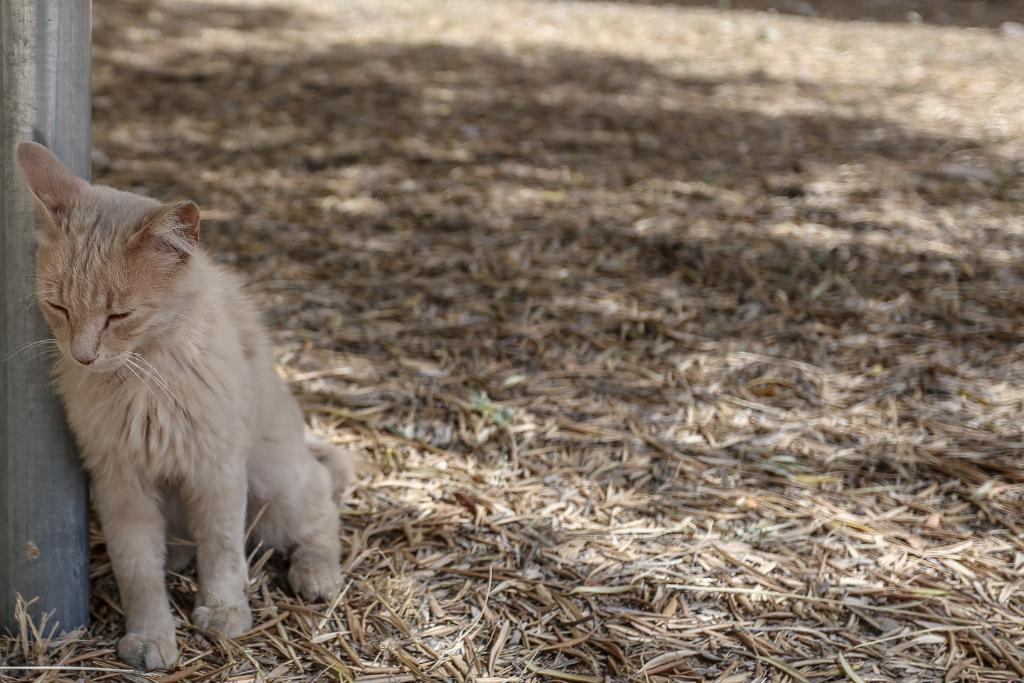What animal can be seen in the image? There is a cat in the image. What is the cat doing in the image? The cat is leaning on a pole. What type of vegetation is visible in the background of the image? There are dry grasses visible in the background of the image. Where are the grasses located in relation to the cat? The grasses are on the ground in the background. What type of screw can be seen holding the cat to the pole in the image? There is no screw visible in the image, and the cat is not attached to the pole. What color is the zebra in the image? There is no zebra present in the image. 